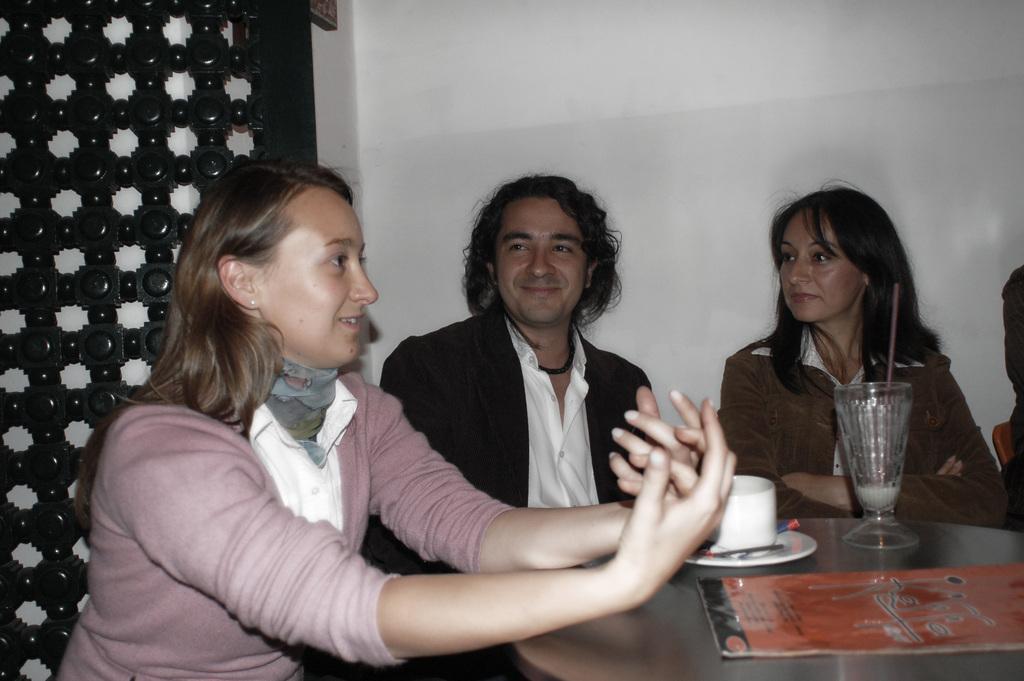Describe this image in one or two sentences. In this image there are people sitting on the chairs. In front of them there is a table. On top of it there is a glass with the straw in it and there are some other objects. Behind them there is a wall. On the left side of the image there is a wooden structure with holes. 